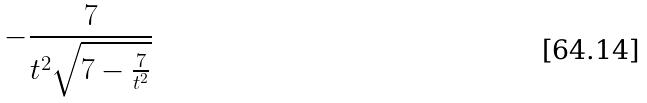Convert formula to latex. <formula><loc_0><loc_0><loc_500><loc_500>- \frac { 7 } { t ^ { 2 } \sqrt { 7 - \frac { 7 } { t ^ { 2 } } } }</formula> 